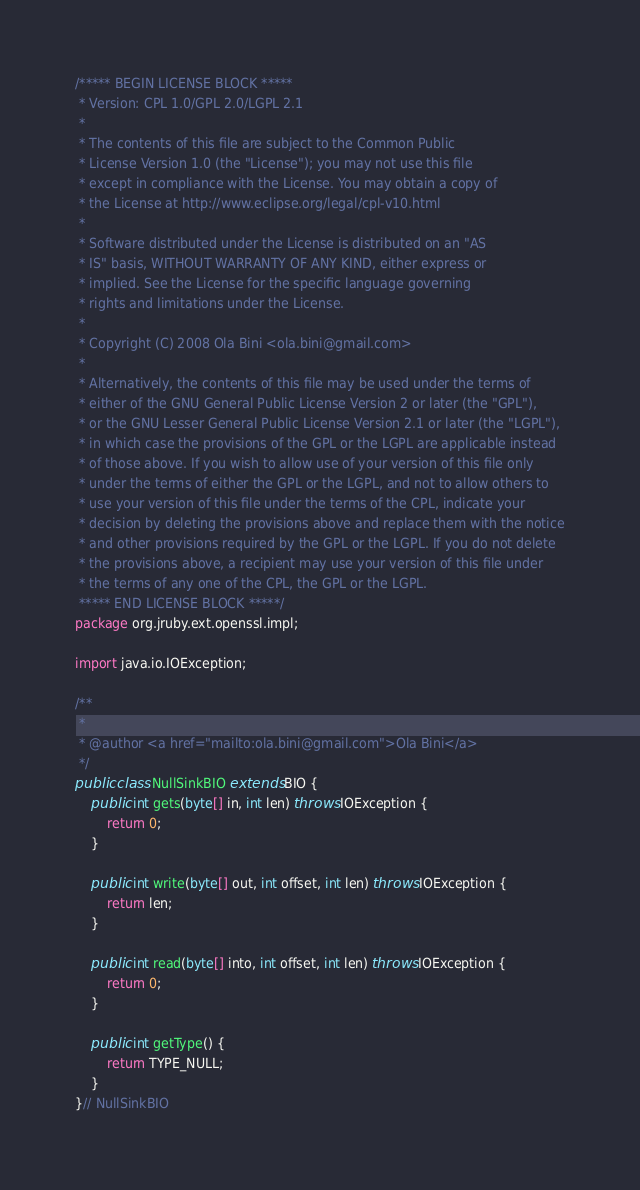<code> <loc_0><loc_0><loc_500><loc_500><_Java_>/***** BEGIN LICENSE BLOCK *****
 * Version: CPL 1.0/GPL 2.0/LGPL 2.1
 *
 * The contents of this file are subject to the Common Public
 * License Version 1.0 (the "License"); you may not use this file
 * except in compliance with the License. You may obtain a copy of
 * the License at http://www.eclipse.org/legal/cpl-v10.html
 *
 * Software distributed under the License is distributed on an "AS
 * IS" basis, WITHOUT WARRANTY OF ANY KIND, either express or
 * implied. See the License for the specific language governing
 * rights and limitations under the License.
 *
 * Copyright (C) 2008 Ola Bini <ola.bini@gmail.com>
 * 
 * Alternatively, the contents of this file may be used under the terms of
 * either of the GNU General Public License Version 2 or later (the "GPL"),
 * or the GNU Lesser General Public License Version 2.1 or later (the "LGPL"),
 * in which case the provisions of the GPL or the LGPL are applicable instead
 * of those above. If you wish to allow use of your version of this file only
 * under the terms of either the GPL or the LGPL, and not to allow others to
 * use your version of this file under the terms of the CPL, indicate your
 * decision by deleting the provisions above and replace them with the notice
 * and other provisions required by the GPL or the LGPL. If you do not delete
 * the provisions above, a recipient may use your version of this file under
 * the terms of any one of the CPL, the GPL or the LGPL.
 ***** END LICENSE BLOCK *****/
package org.jruby.ext.openssl.impl;

import java.io.IOException;

/**
 *
 * @author <a href="mailto:ola.bini@gmail.com">Ola Bini</a>
 */
public class NullSinkBIO extends BIO {
    public int gets(byte[] in, int len) throws IOException {
        return 0;
    }

    public int write(byte[] out, int offset, int len) throws IOException {
        return len;
    }

    public int read(byte[] into, int offset, int len) throws IOException {
        return 0;
    }

    public int getType() {
        return TYPE_NULL;
    }
}// NullSinkBIO
</code> 